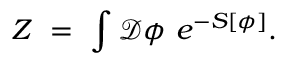<formula> <loc_0><loc_0><loc_500><loc_500>Z \ = \ \int \mathcal { D } \phi \ e ^ { - S [ \phi ] } .</formula> 